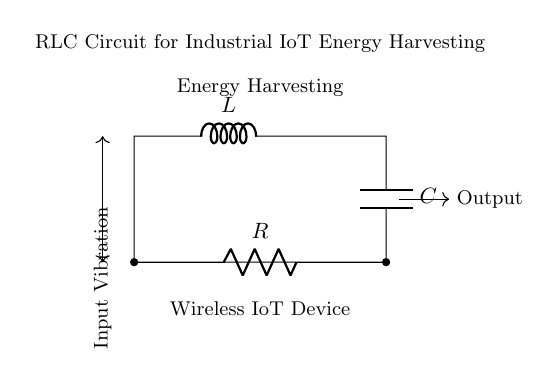What components are present in this circuit? The circuit contains a resistor, an inductor, and a capacitor, indicated by the labels R, L, and C respectively.
Answer: resistor, inductor, capacitor What is the primary function of this RLC circuit? The primary function of the RLC circuit is energy harvesting from input vibrations as indicated by the label "Energy Harvesting."
Answer: energy harvesting How are the components connected in the circuit? The components are connected in parallel with each other (R, L, and C connected between the same two points). The circuit forms a closed loop.
Answer: parallel What is the significance of the input vibration in this circuit? Input vibration acts as the energy source that drives the circuit, allowing it to harvest energy for the wireless IoT device.
Answer: energy source What type of circuit is used for industrial IoT energy harvesting? This circuit is an RLC circuit specifically designed for energy harvesting applications, suitable for wireless IoT devices.
Answer: RLC circuit How does the RLC circuit influence energy storage? The combination of R, L, and C in the circuit allows for energy storage and release, optimizing energy transfer based on their impedance characteristics.
Answer: energy storage 